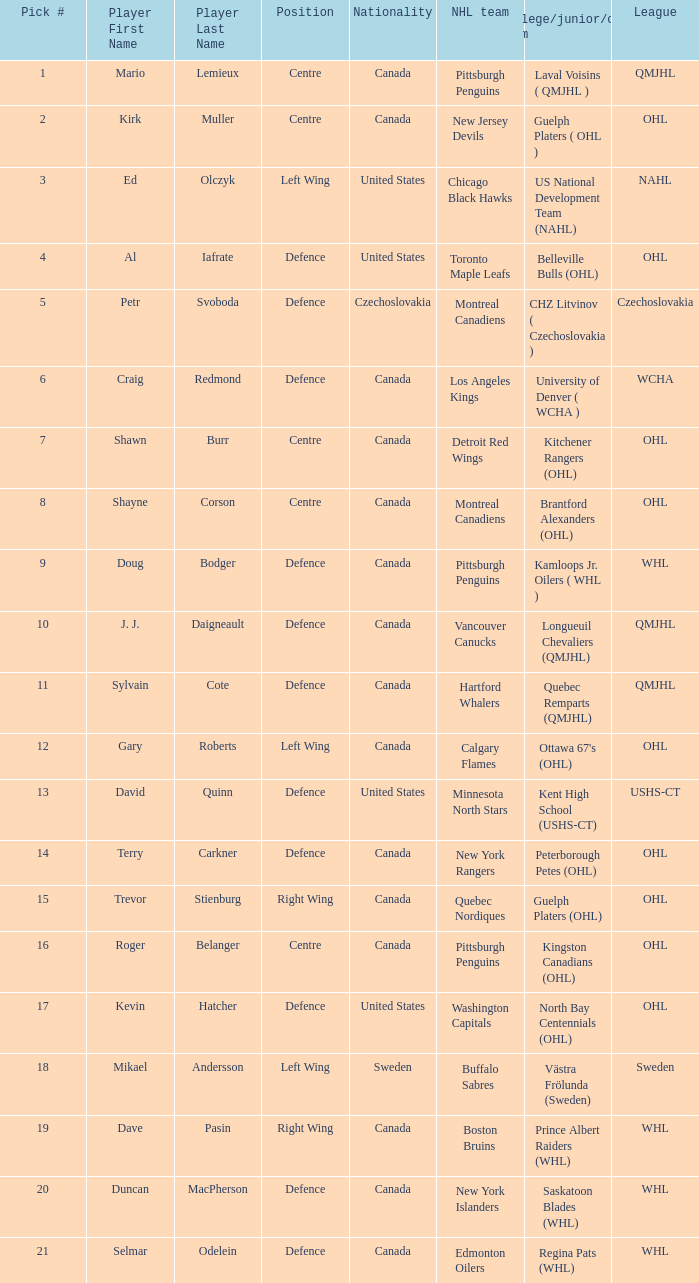What daft pick number is the player coming from Regina Pats (WHL)? 21.0. 